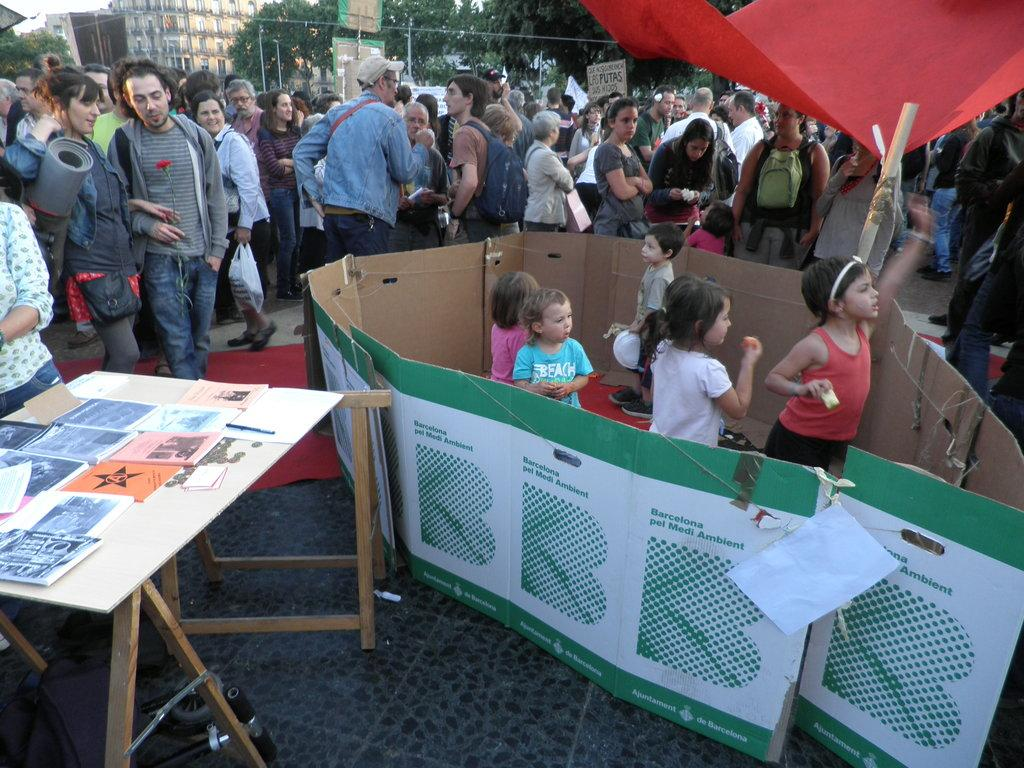How many people are in the group visible in the image? There is a group of people standing in the image, but the exact number cannot be determined from the provided facts. What is on the table in the image? There is a table in the image, and there are papers on the table. Are there any children in the image? Yes, there are kids standing in the image. What can be seen in the background of the image? There are buildings and trees visible in the image. What type of poison is being used to answer questions in the image? There is no indication of any poison or questions being present in the image. How many necks are visible in the image? The provided facts do not mention any necks, so it cannot be determined from the image. 